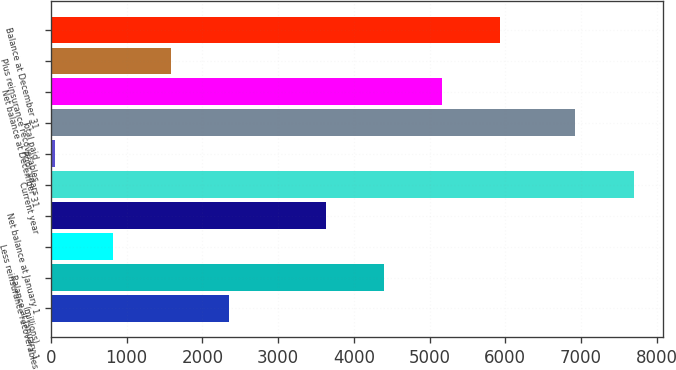<chart> <loc_0><loc_0><loc_500><loc_500><bar_chart><fcel>(millions)<fcel>Balance at January 1<fcel>Less reinsurance recoverables<fcel>Net balance at January 1<fcel>Current year<fcel>Prior years<fcel>Total paid<fcel>Net balance at December 31<fcel>Plus reinsurance recoverables<fcel>Balance at December 31<nl><fcel>2348.22<fcel>4396.14<fcel>820.14<fcel>3632.1<fcel>7696.5<fcel>56.1<fcel>6926.1<fcel>5160.18<fcel>1584.18<fcel>5924.22<nl></chart> 